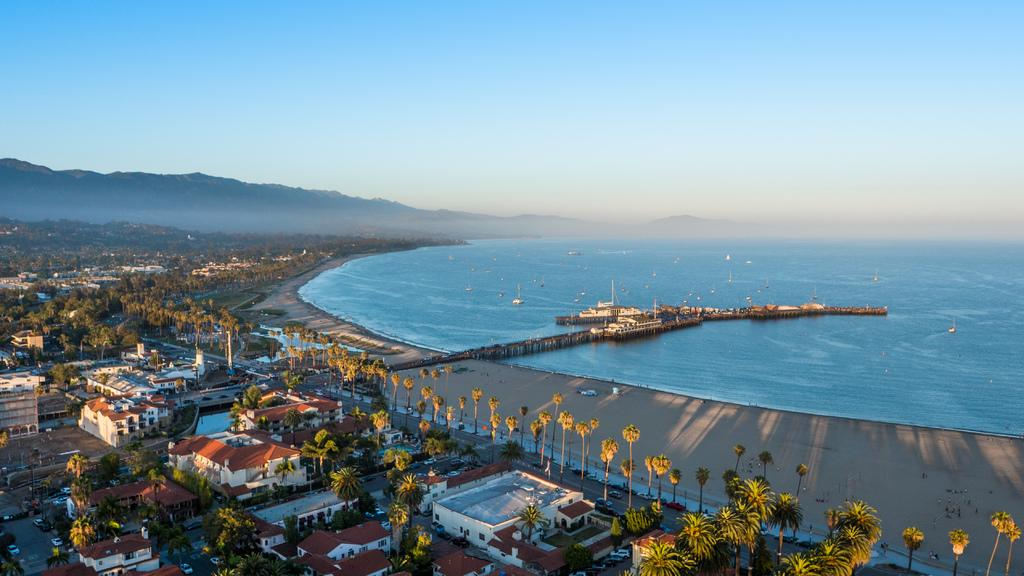What is located at the bottom of the image? There are trees, houses, and vehicles at the bottom of the image. What can be seen in the middle of the image? There are boats, trees, water, a bridge, and people in the middle of the image. What type of terrain is visible in the middle of the image? There are hills in the middle of the image. What part of the natural environment is visible in the image? The sky is visible in the image. What type of story is being told by the drawer in the image? There is no drawer present in the image, so no story can be associated with it. How does the support system for the trees in the image function? The image does not provide information about the support system for the trees, as it only shows the trees themselves. 